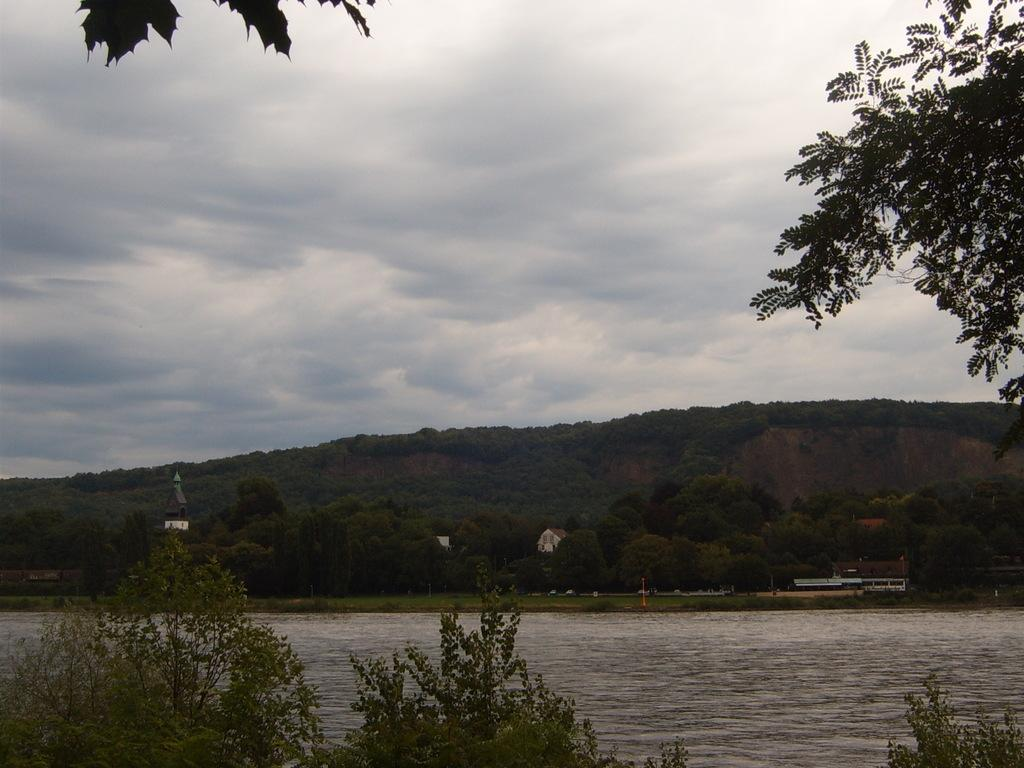What is present in the image that represents a natural element? There is water in the image, which represents a natural element. What other natural elements can be seen in the image? There are trees in the image. How would you describe the weather based on the image? The sky is cloudy in the image, which suggests overcast or potentially rainy weather. What type of man-made structures are visible in the background of the image? There are buildings in the background of the image. Can you tell me how many people are getting a haircut in the image? There is no indication of a haircut or any people in the image. What type of quilt is draped over the trees in the image? There is no quilt present in the image; it features water, trees, a cloudy sky, and buildings in the background. 